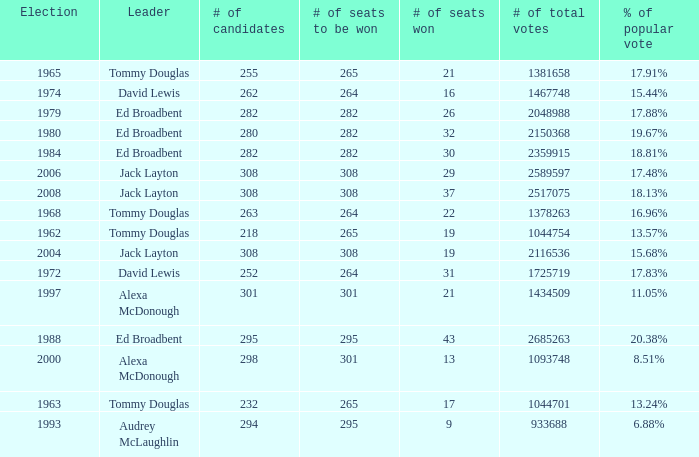Name the number of seats to be won being % of popular vote at 6.88% 295.0. 